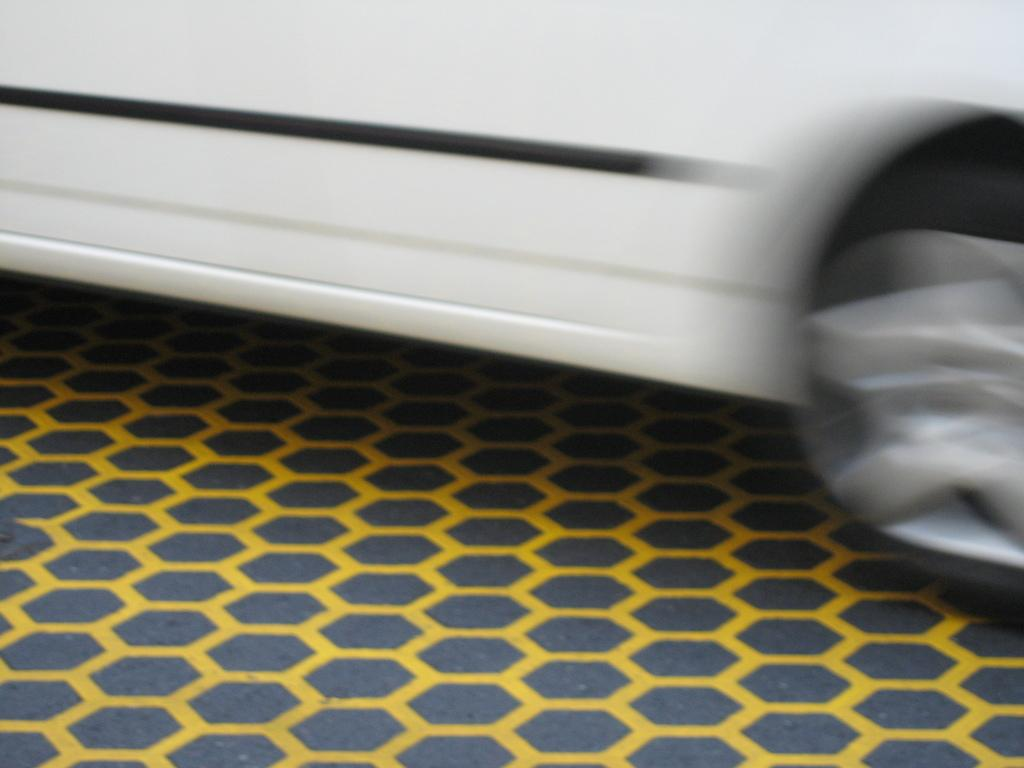What is the main subject of the image? The main subject of the image is a vehicle. Can you describe the position of the vehicle in the image? The vehicle is on the ground in the image. What type of current can be seen flowing through the vehicle in the image? There is no current flowing through the vehicle in the image, as it is a stationary object on the ground. What flag is attached to the vehicle in the image? There is no flag attached to the vehicle in the image. 